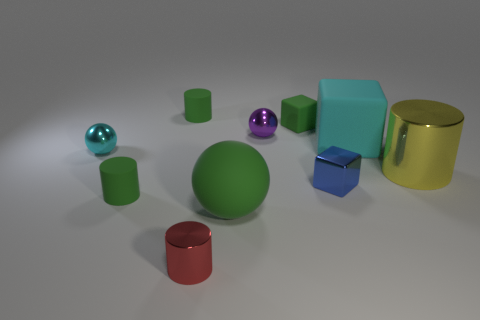Subtract all green cylinders. How many were subtracted if there are1green cylinders left? 1 Subtract all small spheres. How many spheres are left? 1 Subtract all brown cubes. How many green cylinders are left? 2 Subtract all red cylinders. How many cylinders are left? 3 Subtract 1 cylinders. How many cylinders are left? 3 Subtract all blocks. How many objects are left? 7 Subtract all cyan cylinders. Subtract all brown spheres. How many cylinders are left? 4 Subtract all yellow blocks. Subtract all red objects. How many objects are left? 9 Add 7 rubber cylinders. How many rubber cylinders are left? 9 Add 1 large green matte balls. How many large green matte balls exist? 2 